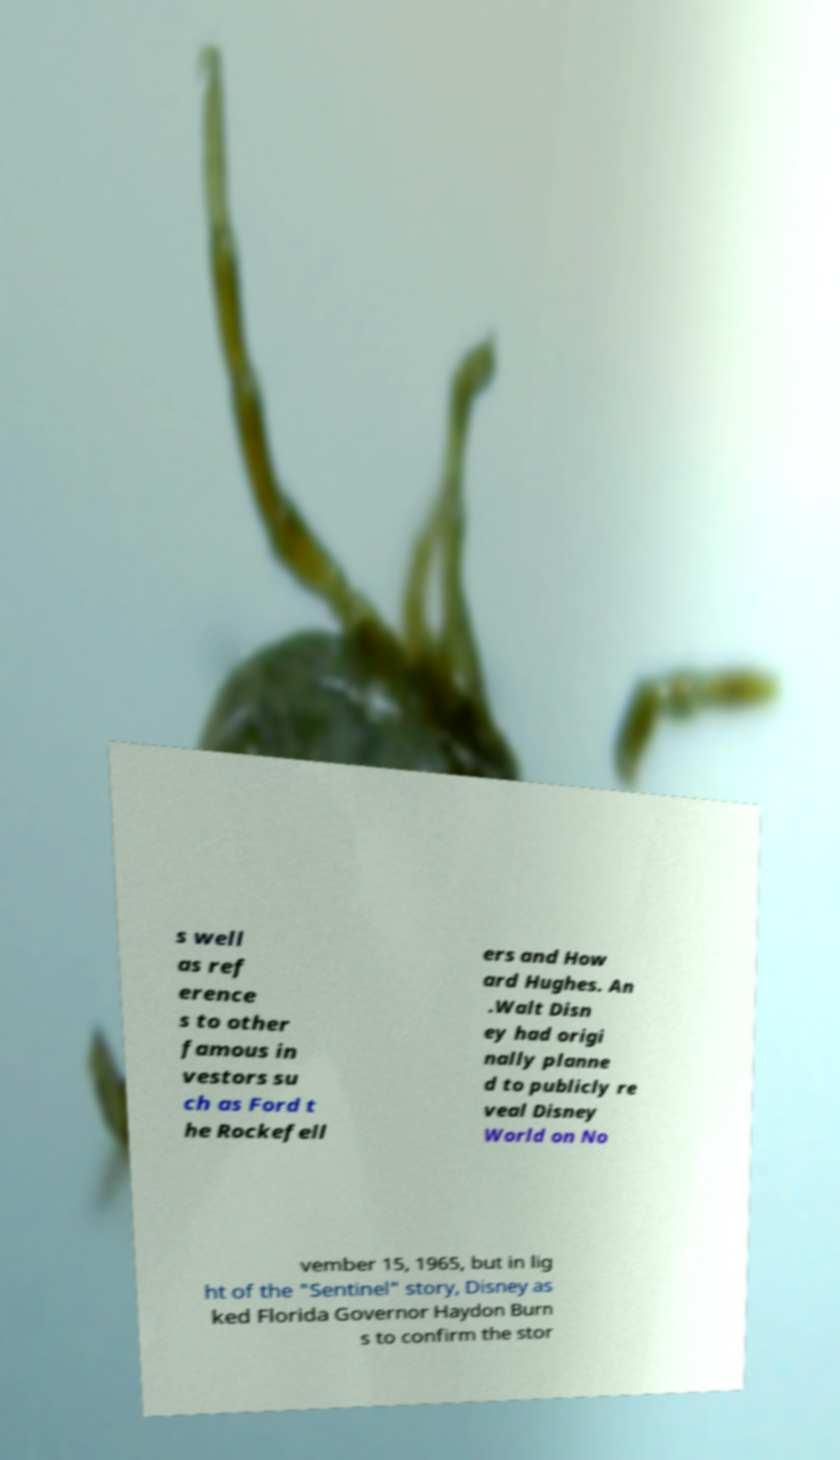There's text embedded in this image that I need extracted. Can you transcribe it verbatim? s well as ref erence s to other famous in vestors su ch as Ford t he Rockefell ers and How ard Hughes. An .Walt Disn ey had origi nally planne d to publicly re veal Disney World on No vember 15, 1965, but in lig ht of the "Sentinel" story, Disney as ked Florida Governor Haydon Burn s to confirm the stor 